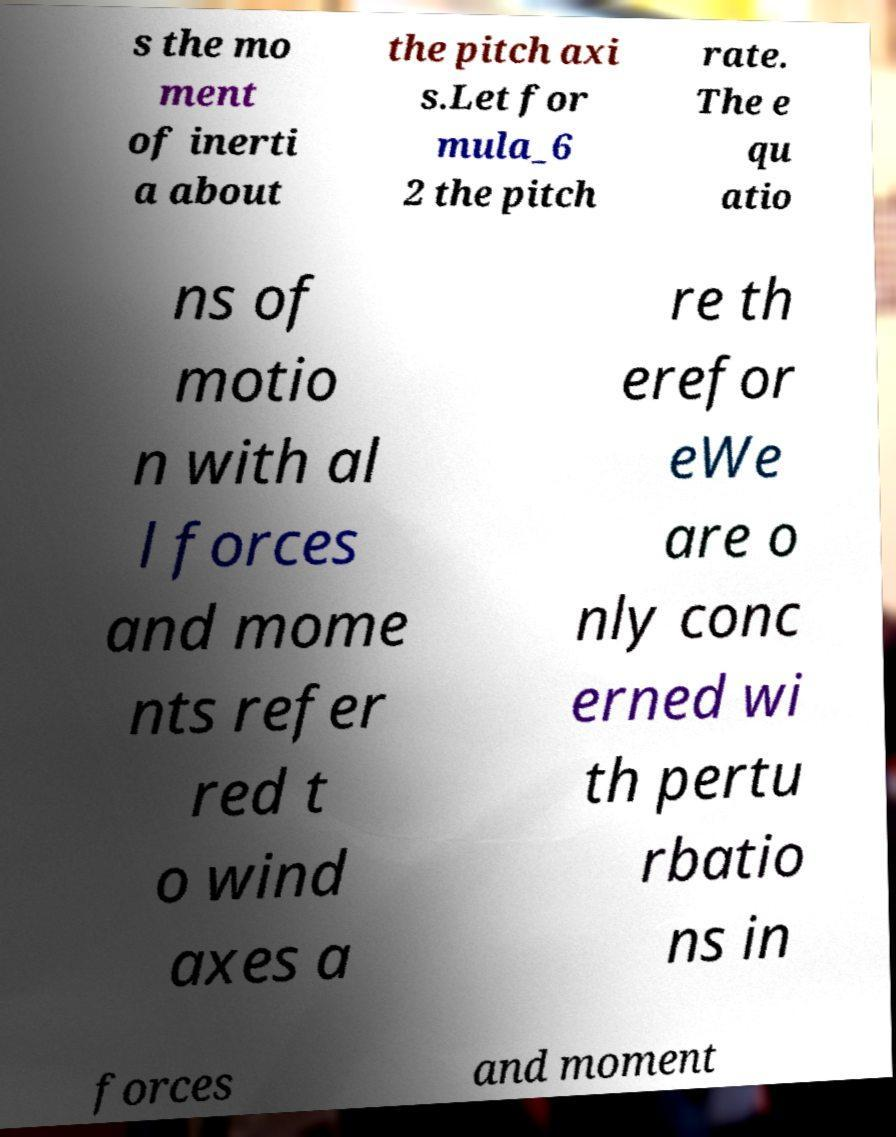Could you extract and type out the text from this image? s the mo ment of inerti a about the pitch axi s.Let for mula_6 2 the pitch rate. The e qu atio ns of motio n with al l forces and mome nts refer red t o wind axes a re th erefor eWe are o nly conc erned wi th pertu rbatio ns in forces and moment 